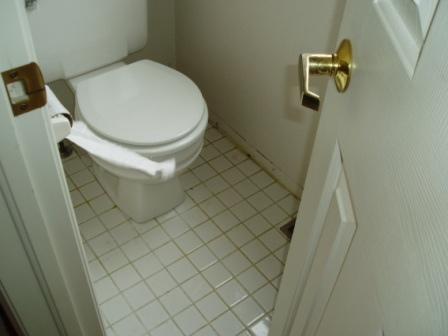How many toilets are there?
Give a very brief answer. 1. 